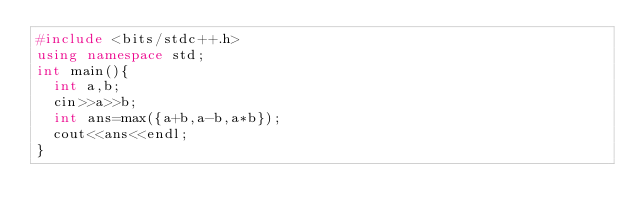<code> <loc_0><loc_0><loc_500><loc_500><_C++_>#include <bits/stdc++.h>
using namespace std;
int main(){
  int a,b;
  cin>>a>>b;
  int ans=max({a+b,a-b,a*b});
  cout<<ans<<endl;
}</code> 